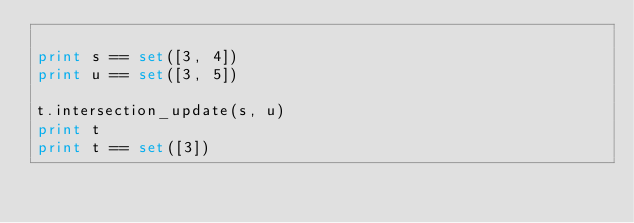<code> <loc_0><loc_0><loc_500><loc_500><_Python_>
print s == set([3, 4])
print u == set([3, 5])

t.intersection_update(s, u)
print t
print t == set([3])

</code> 